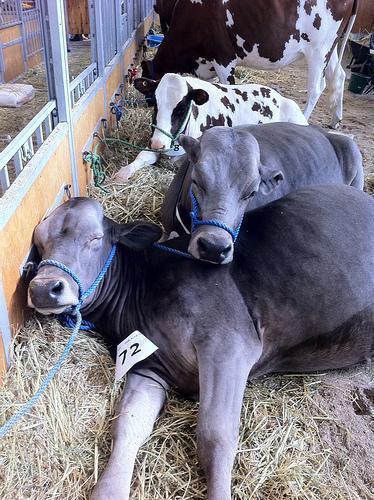How many cows are there?
Give a very brief answer. 4. 